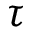<formula> <loc_0><loc_0><loc_500><loc_500>\tau</formula> 